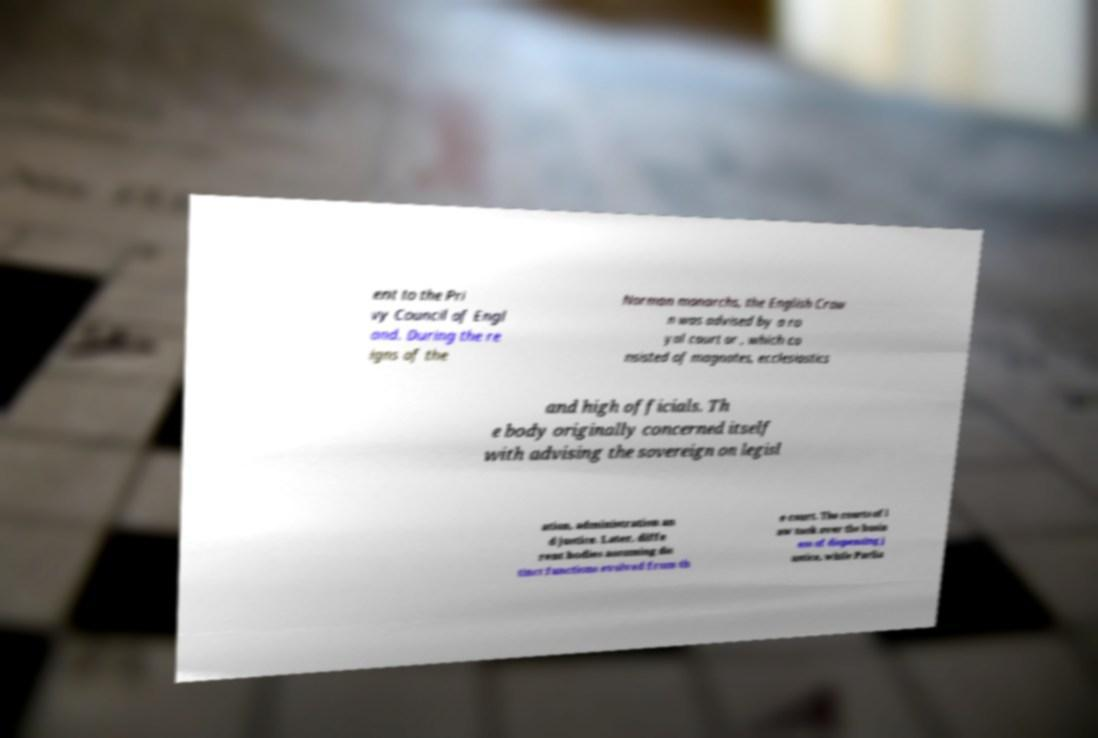There's text embedded in this image that I need extracted. Can you transcribe it verbatim? ent to the Pri vy Council of Engl and. During the re igns of the Norman monarchs, the English Crow n was advised by a ro yal court or , which co nsisted of magnates, ecclesiastics and high officials. Th e body originally concerned itself with advising the sovereign on legisl ation, administration an d justice. Later, diffe rent bodies assuming dis tinct functions evolved from th e court. The courts of l aw took over the busin ess of dispensing j ustice, while Parlia 